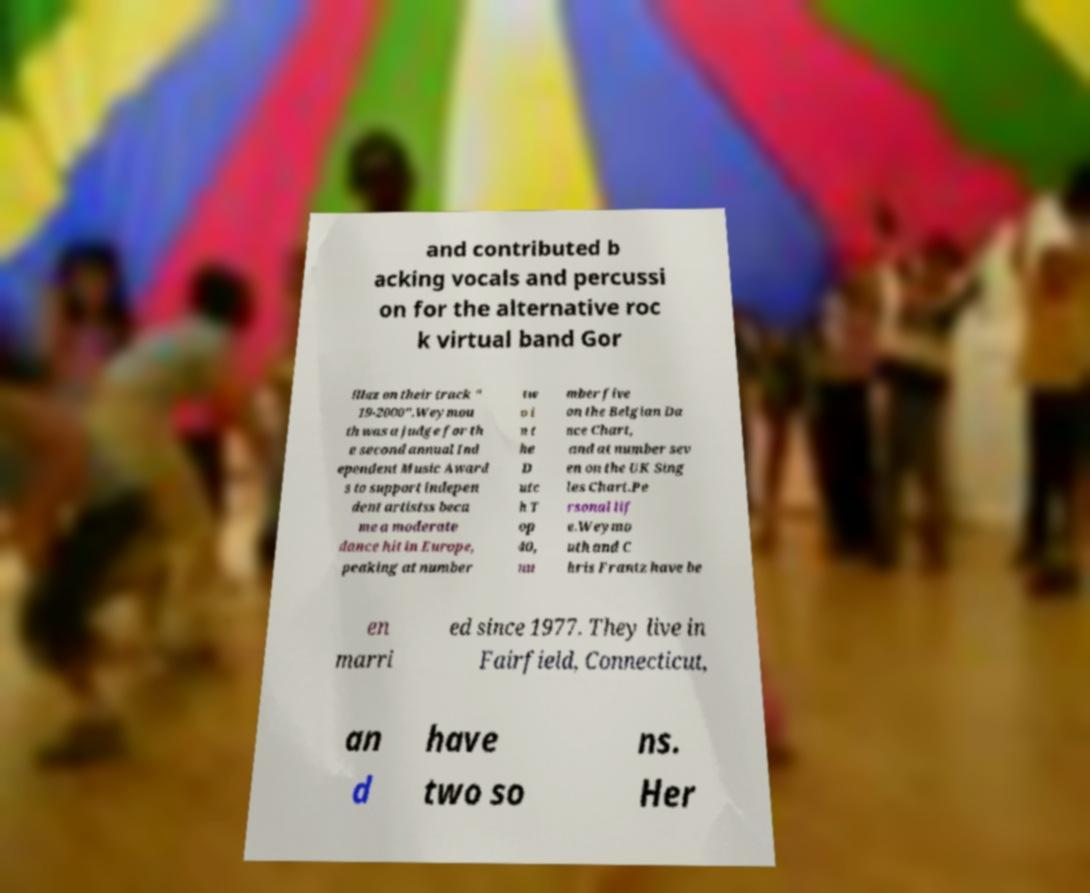There's text embedded in this image that I need extracted. Can you transcribe it verbatim? and contributed b acking vocals and percussi on for the alternative roc k virtual band Gor illaz on their track " 19-2000".Weymou th was a judge for th e second annual Ind ependent Music Award s to support indepen dent artistss beca me a moderate dance hit in Europe, peaking at number tw o i n t he D utc h T op 40, nu mber five on the Belgian Da nce Chart, and at number sev en on the UK Sing les Chart.Pe rsonal lif e.Weymo uth and C hris Frantz have be en marri ed since 1977. They live in Fairfield, Connecticut, an d have two so ns. Her 